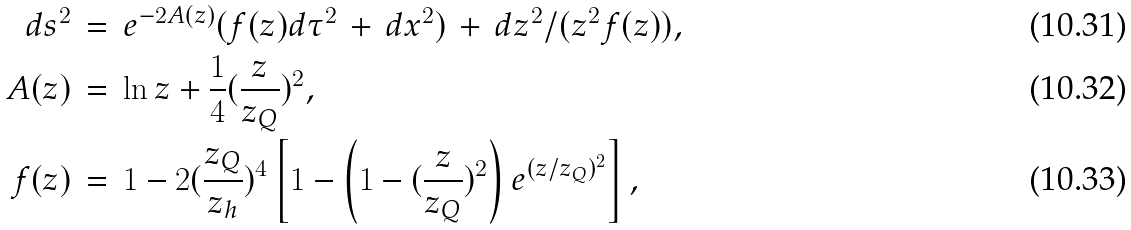<formula> <loc_0><loc_0><loc_500><loc_500>d s ^ { 2 } \, & = \, e ^ { - 2 A ( z ) } ( f ( z ) d \tau ^ { 2 } \, + \, d { x } ^ { 2 } ) \, + \, d z ^ { 2 } / ( z ^ { 2 } f ( z ) ) , \\ A ( z ) \, & = \, \ln z + \frac { 1 } { 4 } ( \frac { z } { z _ { Q } } ) ^ { 2 } , \\ f ( z ) \, & = \, 1 - 2 ( \frac { z _ { Q } } { z _ { h } } ) ^ { 4 } \left [ 1 - \left ( 1 - ( \frac { z } { z _ { Q } } ) ^ { 2 } \right ) e ^ { ( z / z _ { Q } ) ^ { 2 } } \right ] ,</formula> 